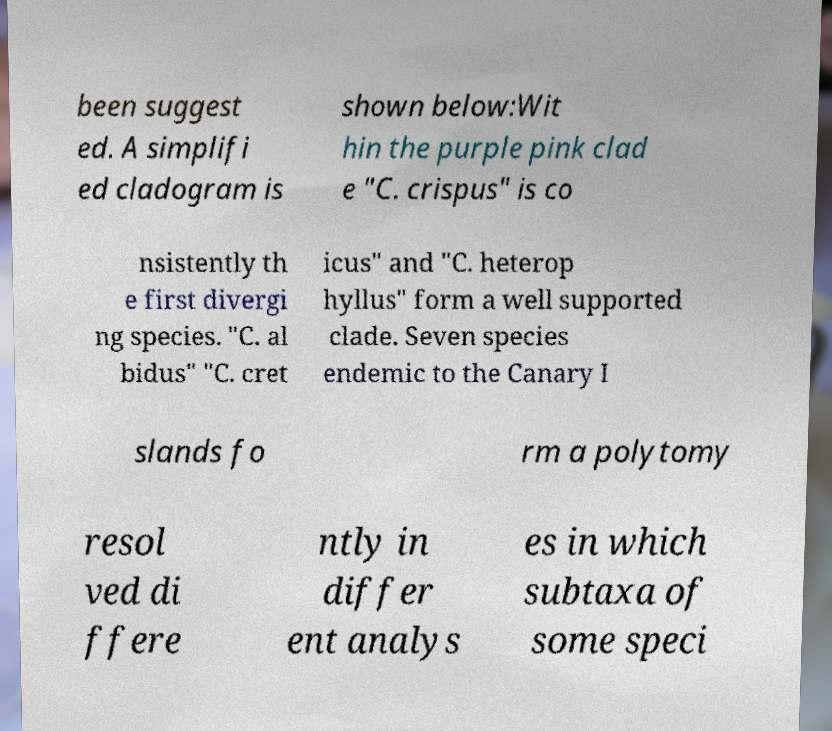Please read and relay the text visible in this image. What does it say? been suggest ed. A simplifi ed cladogram is shown below:Wit hin the purple pink clad e "C. crispus" is co nsistently th e first divergi ng species. "C. al bidus" "C. cret icus" and "C. heterop hyllus" form a well supported clade. Seven species endemic to the Canary I slands fo rm a polytomy resol ved di ffere ntly in differ ent analys es in which subtaxa of some speci 